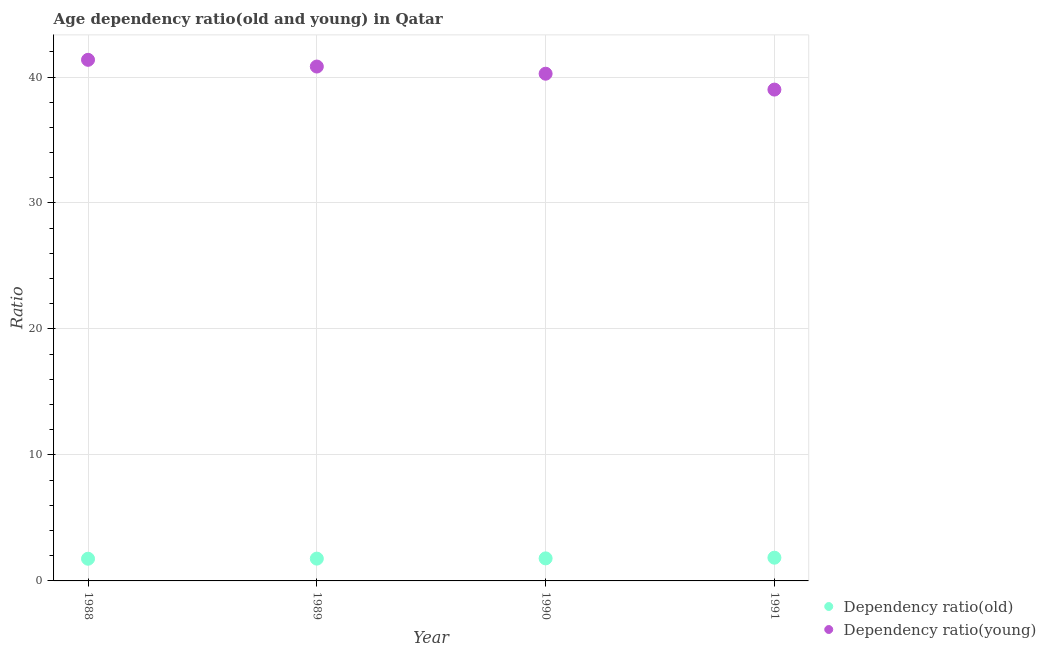How many different coloured dotlines are there?
Provide a succinct answer. 2. What is the age dependency ratio(young) in 1991?
Your answer should be compact. 39. Across all years, what is the maximum age dependency ratio(old)?
Make the answer very short. 1.84. Across all years, what is the minimum age dependency ratio(old)?
Your response must be concise. 1.76. What is the total age dependency ratio(young) in the graph?
Provide a short and direct response. 161.46. What is the difference between the age dependency ratio(young) in 1988 and that in 1990?
Give a very brief answer. 1.1. What is the difference between the age dependency ratio(young) in 1990 and the age dependency ratio(old) in 1988?
Your answer should be compact. 38.5. What is the average age dependency ratio(young) per year?
Your answer should be very brief. 40.37. In the year 1991, what is the difference between the age dependency ratio(young) and age dependency ratio(old)?
Give a very brief answer. 37.16. What is the ratio of the age dependency ratio(young) in 1989 to that in 1991?
Your answer should be very brief. 1.05. What is the difference between the highest and the second highest age dependency ratio(young)?
Make the answer very short. 0.53. What is the difference between the highest and the lowest age dependency ratio(old)?
Provide a succinct answer. 0.08. In how many years, is the age dependency ratio(old) greater than the average age dependency ratio(old) taken over all years?
Offer a terse response. 1. Is the sum of the age dependency ratio(old) in 1988 and 1990 greater than the maximum age dependency ratio(young) across all years?
Your answer should be very brief. No. Does the age dependency ratio(old) monotonically increase over the years?
Make the answer very short. Yes. Is the age dependency ratio(old) strictly greater than the age dependency ratio(young) over the years?
Ensure brevity in your answer.  No. Is the age dependency ratio(young) strictly less than the age dependency ratio(old) over the years?
Make the answer very short. No. How many years are there in the graph?
Your answer should be compact. 4. Are the values on the major ticks of Y-axis written in scientific E-notation?
Make the answer very short. No. Does the graph contain grids?
Your answer should be very brief. Yes. Where does the legend appear in the graph?
Give a very brief answer. Bottom right. What is the title of the graph?
Provide a succinct answer. Age dependency ratio(old and young) in Qatar. What is the label or title of the Y-axis?
Keep it short and to the point. Ratio. What is the Ratio of Dependency ratio(old) in 1988?
Your answer should be very brief. 1.76. What is the Ratio in Dependency ratio(young) in 1988?
Your answer should be very brief. 41.37. What is the Ratio in Dependency ratio(old) in 1989?
Give a very brief answer. 1.77. What is the Ratio in Dependency ratio(young) in 1989?
Your answer should be compact. 40.83. What is the Ratio of Dependency ratio(old) in 1990?
Make the answer very short. 1.79. What is the Ratio of Dependency ratio(young) in 1990?
Make the answer very short. 40.26. What is the Ratio in Dependency ratio(old) in 1991?
Keep it short and to the point. 1.84. What is the Ratio of Dependency ratio(young) in 1991?
Offer a very short reply. 39. Across all years, what is the maximum Ratio of Dependency ratio(old)?
Offer a very short reply. 1.84. Across all years, what is the maximum Ratio of Dependency ratio(young)?
Your answer should be very brief. 41.37. Across all years, what is the minimum Ratio of Dependency ratio(old)?
Offer a terse response. 1.76. Across all years, what is the minimum Ratio in Dependency ratio(young)?
Offer a very short reply. 39. What is the total Ratio in Dependency ratio(old) in the graph?
Make the answer very short. 7.17. What is the total Ratio of Dependency ratio(young) in the graph?
Provide a succinct answer. 161.46. What is the difference between the Ratio of Dependency ratio(old) in 1988 and that in 1989?
Offer a very short reply. -0.01. What is the difference between the Ratio of Dependency ratio(young) in 1988 and that in 1989?
Provide a succinct answer. 0.53. What is the difference between the Ratio of Dependency ratio(old) in 1988 and that in 1990?
Make the answer very short. -0.03. What is the difference between the Ratio of Dependency ratio(young) in 1988 and that in 1990?
Make the answer very short. 1.1. What is the difference between the Ratio of Dependency ratio(old) in 1988 and that in 1991?
Your response must be concise. -0.08. What is the difference between the Ratio in Dependency ratio(young) in 1988 and that in 1991?
Give a very brief answer. 2.36. What is the difference between the Ratio in Dependency ratio(old) in 1989 and that in 1990?
Offer a very short reply. -0.02. What is the difference between the Ratio of Dependency ratio(young) in 1989 and that in 1990?
Provide a succinct answer. 0.57. What is the difference between the Ratio of Dependency ratio(old) in 1989 and that in 1991?
Offer a terse response. -0.07. What is the difference between the Ratio in Dependency ratio(young) in 1989 and that in 1991?
Provide a succinct answer. 1.83. What is the difference between the Ratio in Dependency ratio(old) in 1990 and that in 1991?
Provide a short and direct response. -0.05. What is the difference between the Ratio of Dependency ratio(young) in 1990 and that in 1991?
Provide a short and direct response. 1.26. What is the difference between the Ratio of Dependency ratio(old) in 1988 and the Ratio of Dependency ratio(young) in 1989?
Keep it short and to the point. -39.07. What is the difference between the Ratio of Dependency ratio(old) in 1988 and the Ratio of Dependency ratio(young) in 1990?
Offer a terse response. -38.5. What is the difference between the Ratio in Dependency ratio(old) in 1988 and the Ratio in Dependency ratio(young) in 1991?
Ensure brevity in your answer.  -37.24. What is the difference between the Ratio in Dependency ratio(old) in 1989 and the Ratio in Dependency ratio(young) in 1990?
Keep it short and to the point. -38.49. What is the difference between the Ratio in Dependency ratio(old) in 1989 and the Ratio in Dependency ratio(young) in 1991?
Make the answer very short. -37.23. What is the difference between the Ratio of Dependency ratio(old) in 1990 and the Ratio of Dependency ratio(young) in 1991?
Offer a terse response. -37.21. What is the average Ratio of Dependency ratio(old) per year?
Offer a terse response. 1.79. What is the average Ratio of Dependency ratio(young) per year?
Offer a very short reply. 40.37. In the year 1988, what is the difference between the Ratio of Dependency ratio(old) and Ratio of Dependency ratio(young)?
Your answer should be compact. -39.6. In the year 1989, what is the difference between the Ratio of Dependency ratio(old) and Ratio of Dependency ratio(young)?
Your answer should be compact. -39.06. In the year 1990, what is the difference between the Ratio of Dependency ratio(old) and Ratio of Dependency ratio(young)?
Keep it short and to the point. -38.47. In the year 1991, what is the difference between the Ratio of Dependency ratio(old) and Ratio of Dependency ratio(young)?
Make the answer very short. -37.16. What is the ratio of the Ratio of Dependency ratio(old) in 1988 to that in 1989?
Provide a succinct answer. 1. What is the ratio of the Ratio in Dependency ratio(young) in 1988 to that in 1989?
Your answer should be very brief. 1.01. What is the ratio of the Ratio in Dependency ratio(old) in 1988 to that in 1990?
Your answer should be compact. 0.98. What is the ratio of the Ratio in Dependency ratio(young) in 1988 to that in 1990?
Your answer should be very brief. 1.03. What is the ratio of the Ratio of Dependency ratio(old) in 1988 to that in 1991?
Provide a short and direct response. 0.96. What is the ratio of the Ratio in Dependency ratio(young) in 1988 to that in 1991?
Ensure brevity in your answer.  1.06. What is the ratio of the Ratio in Dependency ratio(old) in 1989 to that in 1990?
Your response must be concise. 0.99. What is the ratio of the Ratio in Dependency ratio(young) in 1989 to that in 1990?
Provide a succinct answer. 1.01. What is the ratio of the Ratio of Dependency ratio(old) in 1989 to that in 1991?
Your answer should be very brief. 0.96. What is the ratio of the Ratio of Dependency ratio(young) in 1989 to that in 1991?
Give a very brief answer. 1.05. What is the ratio of the Ratio in Dependency ratio(old) in 1990 to that in 1991?
Your response must be concise. 0.97. What is the ratio of the Ratio of Dependency ratio(young) in 1990 to that in 1991?
Your answer should be compact. 1.03. What is the difference between the highest and the second highest Ratio in Dependency ratio(old)?
Ensure brevity in your answer.  0.05. What is the difference between the highest and the second highest Ratio in Dependency ratio(young)?
Offer a very short reply. 0.53. What is the difference between the highest and the lowest Ratio in Dependency ratio(old)?
Make the answer very short. 0.08. What is the difference between the highest and the lowest Ratio in Dependency ratio(young)?
Make the answer very short. 2.36. 